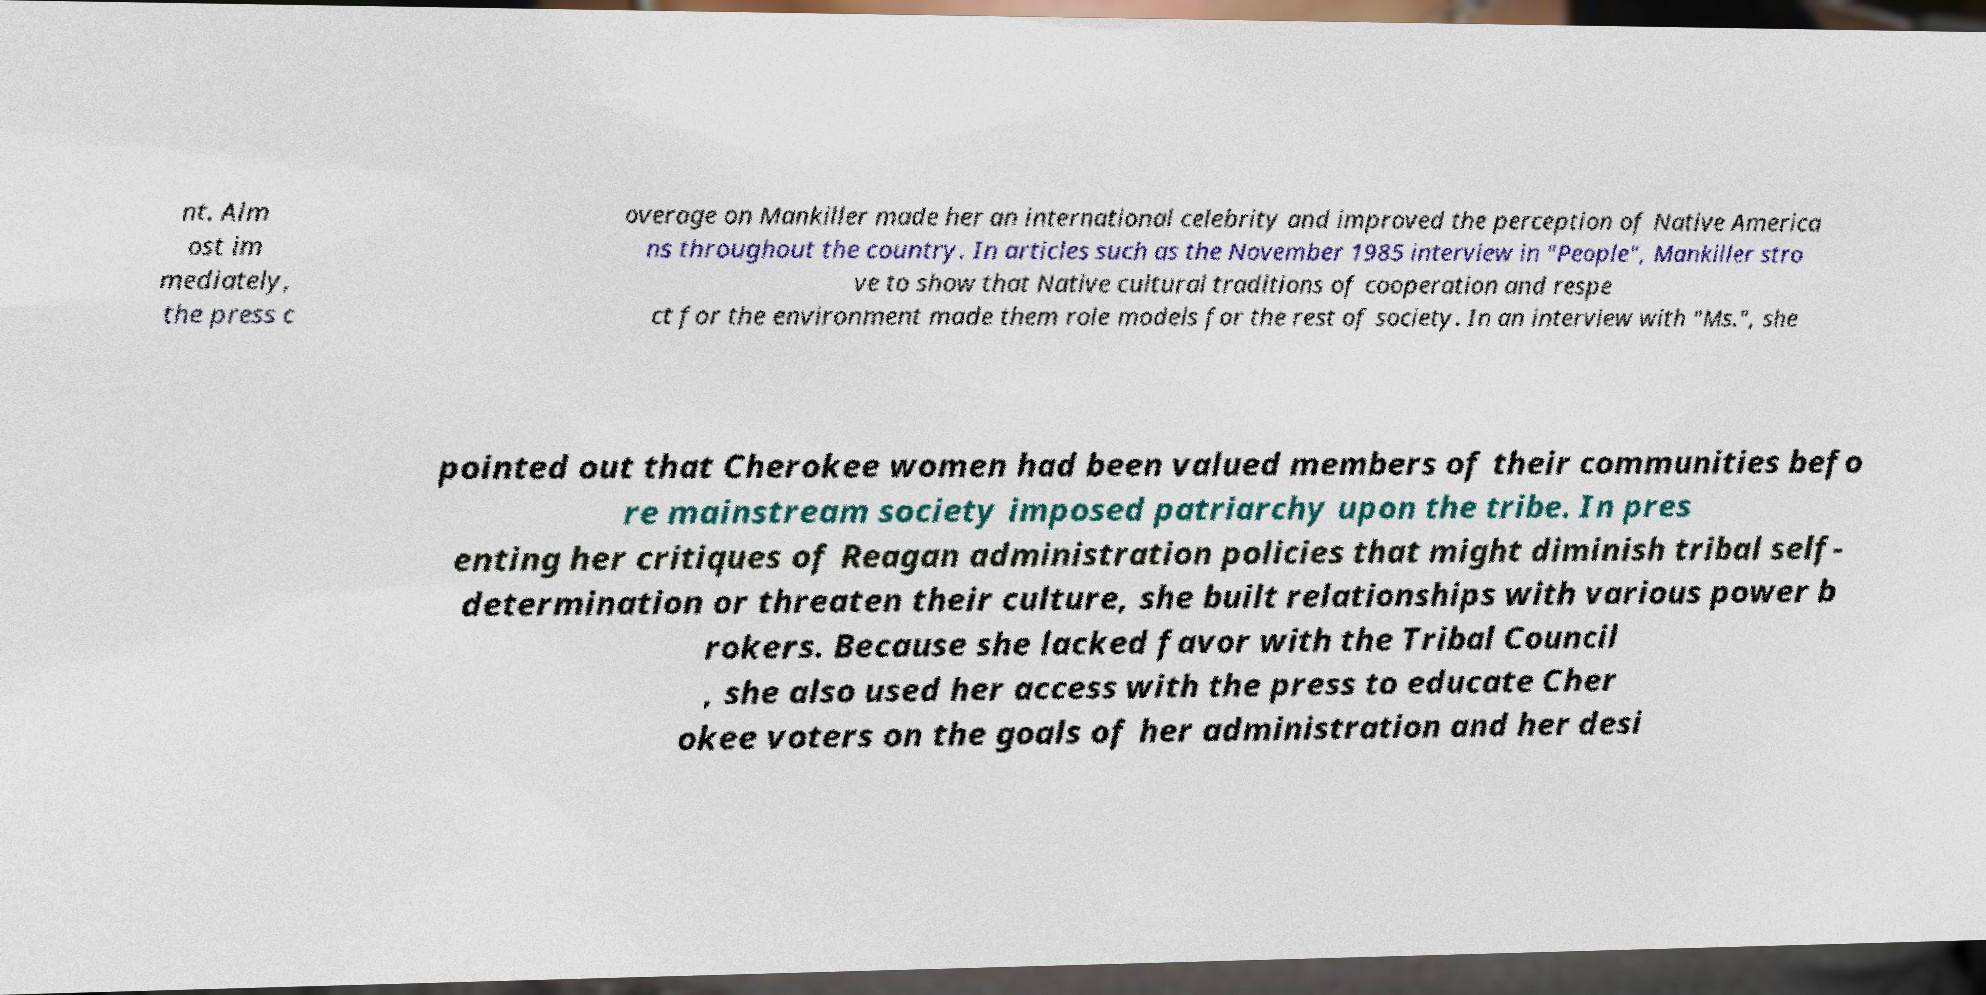Could you assist in decoding the text presented in this image and type it out clearly? nt. Alm ost im mediately, the press c overage on Mankiller made her an international celebrity and improved the perception of Native America ns throughout the country. In articles such as the November 1985 interview in "People", Mankiller stro ve to show that Native cultural traditions of cooperation and respe ct for the environment made them role models for the rest of society. In an interview with "Ms.", she pointed out that Cherokee women had been valued members of their communities befo re mainstream society imposed patriarchy upon the tribe. In pres enting her critiques of Reagan administration policies that might diminish tribal self- determination or threaten their culture, she built relationships with various power b rokers. Because she lacked favor with the Tribal Council , she also used her access with the press to educate Cher okee voters on the goals of her administration and her desi 